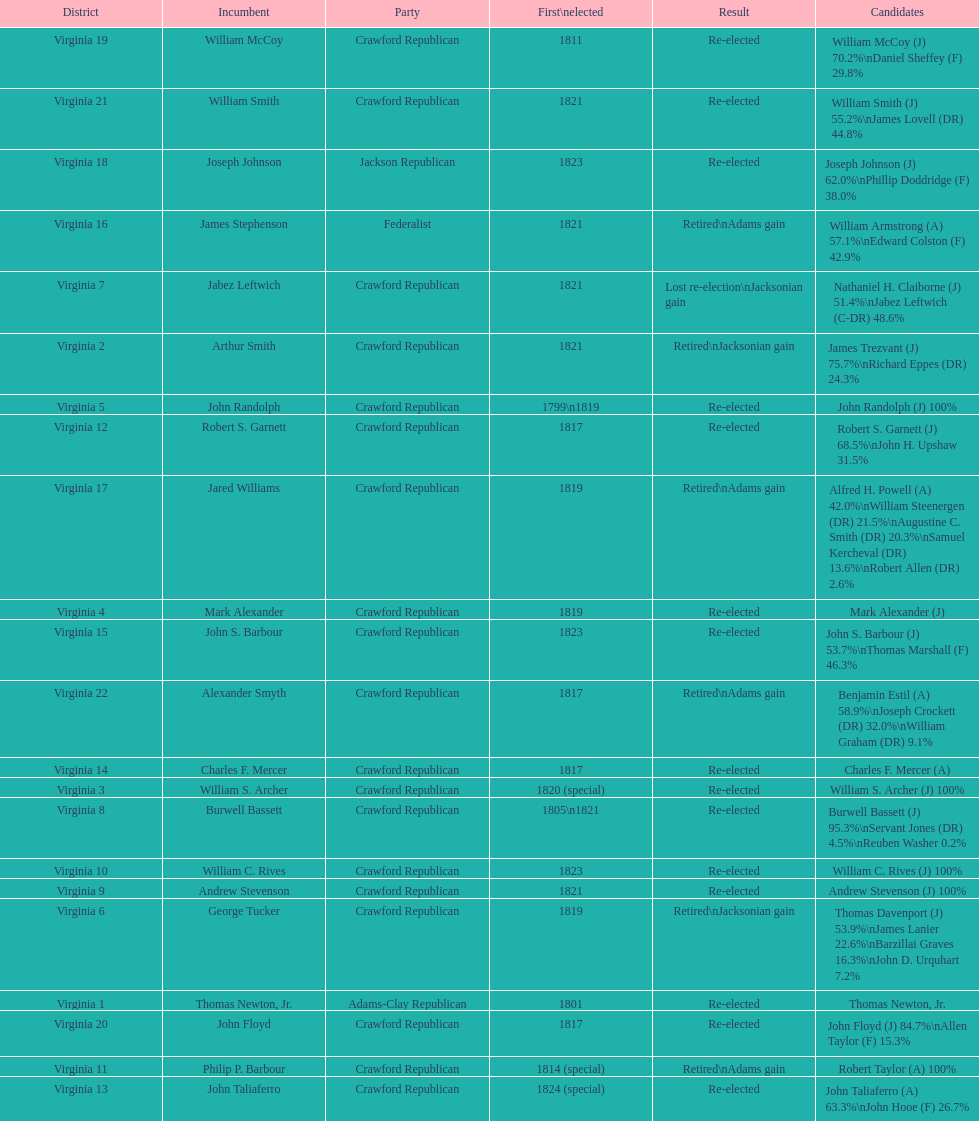How many candidates were there for virginia 17 district? 5. 